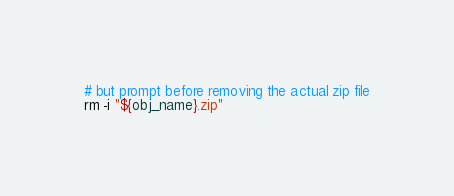Convert code to text. <code><loc_0><loc_0><loc_500><loc_500><_Bash_># but prompt before removing the actual zip file
rm -i "${obj_name}.zip"
</code> 